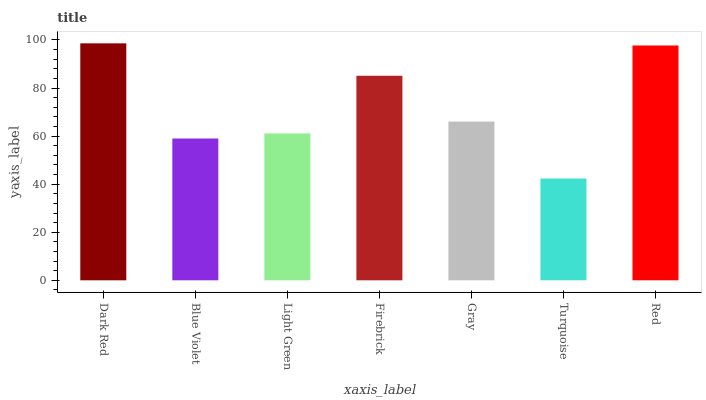Is Turquoise the minimum?
Answer yes or no. Yes. Is Dark Red the maximum?
Answer yes or no. Yes. Is Blue Violet the minimum?
Answer yes or no. No. Is Blue Violet the maximum?
Answer yes or no. No. Is Dark Red greater than Blue Violet?
Answer yes or no. Yes. Is Blue Violet less than Dark Red?
Answer yes or no. Yes. Is Blue Violet greater than Dark Red?
Answer yes or no. No. Is Dark Red less than Blue Violet?
Answer yes or no. No. Is Gray the high median?
Answer yes or no. Yes. Is Gray the low median?
Answer yes or no. Yes. Is Red the high median?
Answer yes or no. No. Is Turquoise the low median?
Answer yes or no. No. 